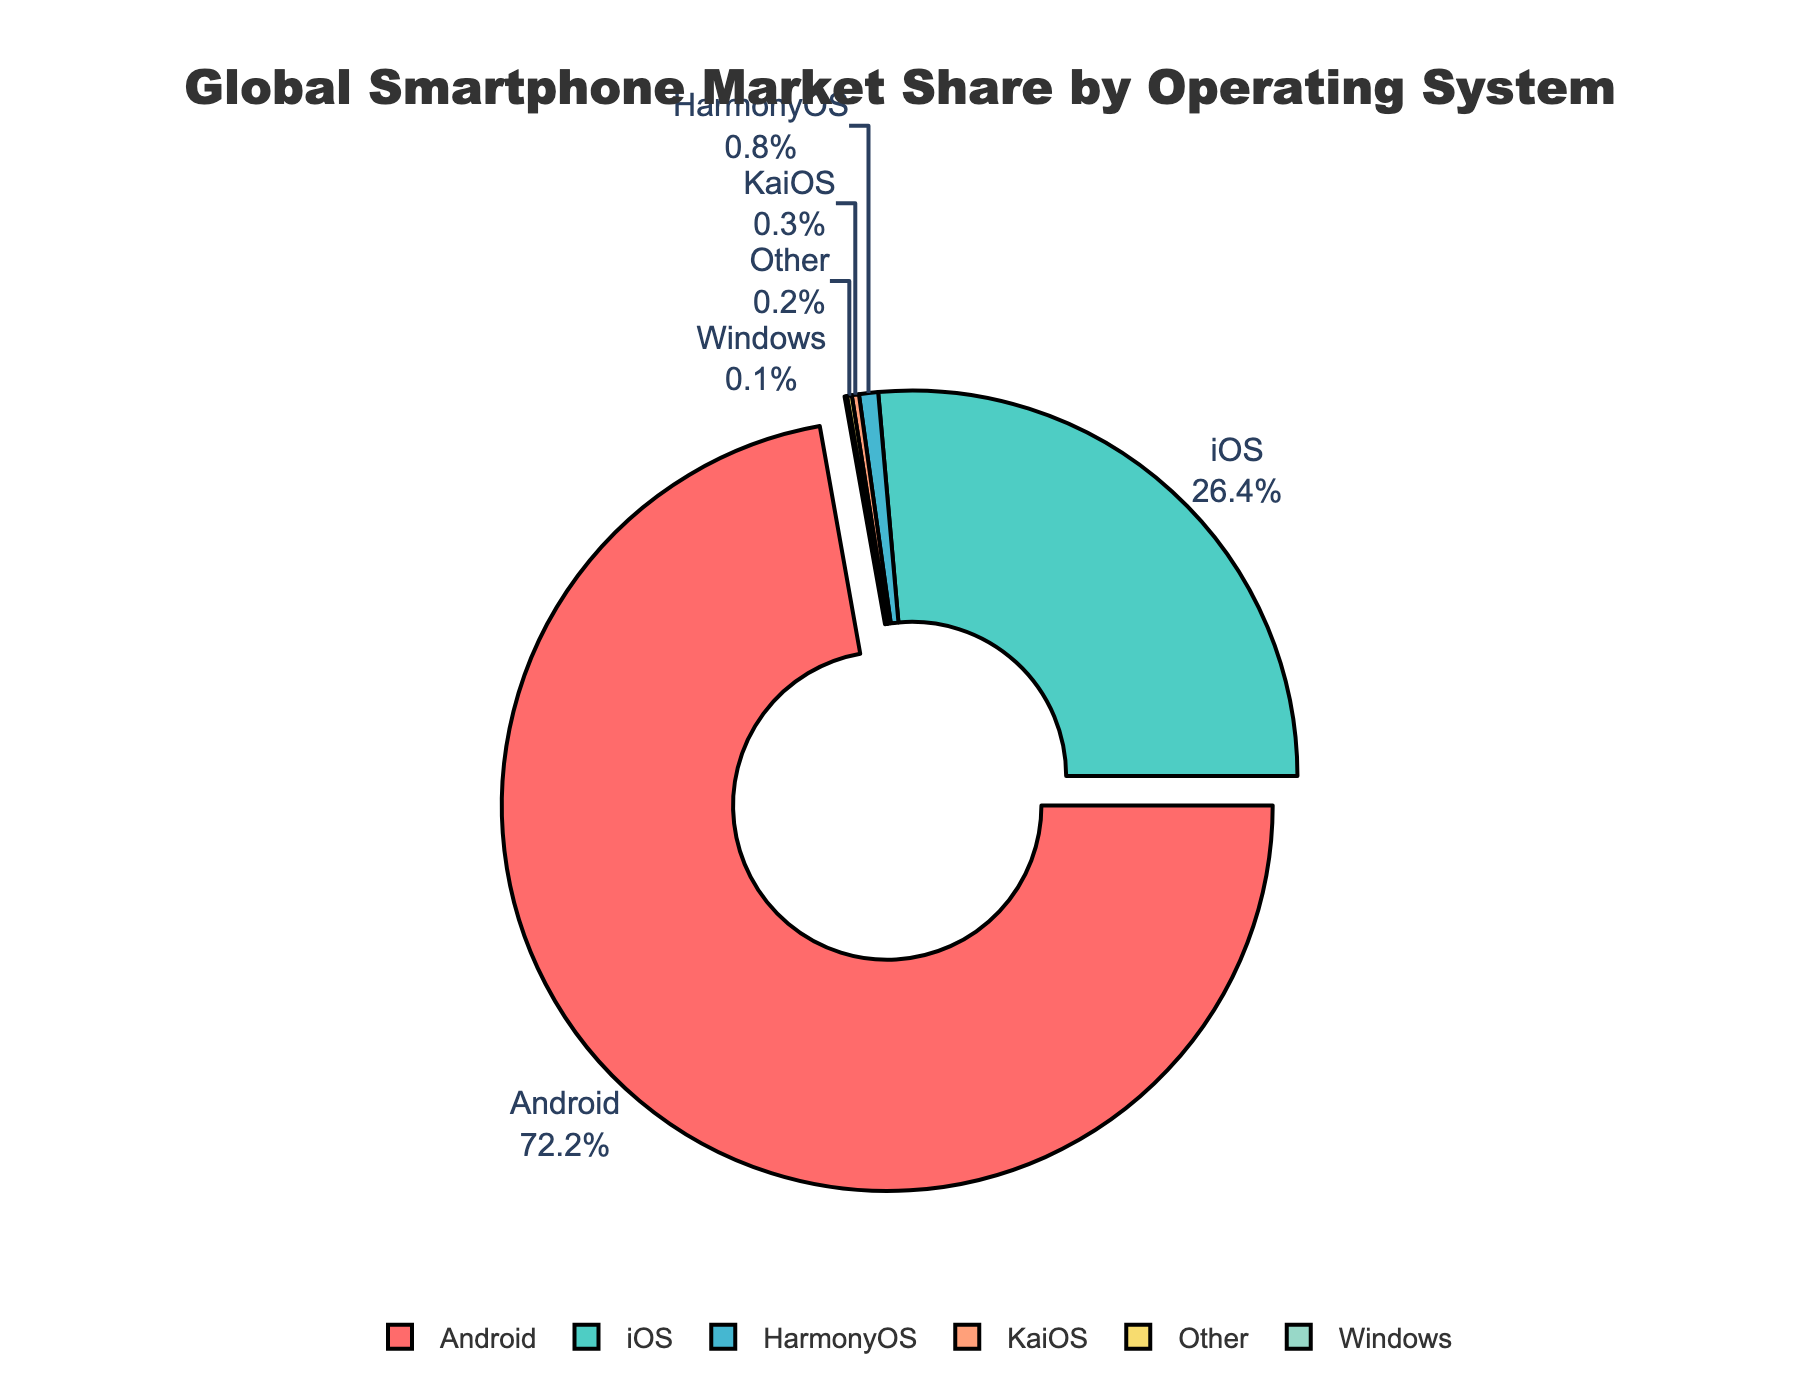What percentage of the market share is held by the top two operating systems combined? Add the market shares of Android (72.2%) and iOS (26.4%) together. Therefore, 72.2 + 26.4 = 98.6%.
Answer: 98.6% Which operating system has the smallest market share, and what is its value? By examining the pie chart, the operating system with the smallest market share is Windows with 0.1%.
Answer: Windows, 0.1% How much larger is Android's market share compared to iOS's market share? Subtract the market share of iOS (26.4%) from Android's market share (72.2%). Therefore, 72.2 - 26.4 = 45.8%.
Answer: 45.8% Ordering from smallest to largest, what are the market shares of the operating systems besides Android and iOS? List the market shares in ascending order: Windows (0.1%), Other (0.2%), KaiOS (0.3%), and HarmonyOS (0.8%).
Answer: Windows: 0.1%, Other: 0.2%, KaiOS: 0.3%, HarmonyOS: 0.8% What color represents the ‘Other’ operating system, and what fraction of the pie chart does it cover? The ‘Other’ operating system is represented by a yellow color and it covers 0.2% of the pie chart. To convert to a fraction, 0.2% out of 100% is 0.2/100 or 1/500.
Answer: Yellow, 1/500 Which operating system is highlighted, and why might this be? Android is highlighted by being pulled out from the rest of the pie chart, likely to emphasize its dominant market share.
Answer: Android Compare the combined market share of HarmonyOS and KaiOS to iOS. Which one is greater and by how much? Combine HarmonyOS (0.8%) and KaiOS (0.3%) for a total of 1.1%; compare this to iOS at 26.4%. iOS is greater by 26.4 - 1.1 = 25.3%.
Answer: iOS, by 25.3% If you were to combine the market shares of all the minor operating systems (HarmonyOS, KaiOS, Windows, and Other), what would be their total market share? Add the market shares of HarmonyOS (0.8%), KaiOS (0.3%), Windows (0.1%), and Other (0.2%) for a total of 1.4%.
Answer: 1.4% What is the visual characteristic used to differentiate Android from the other segments in the pie chart? Android is differentiated by being slightly pulled outwards from the center of the pie chart.
Answer: Pulled outwards If you were to remove the smallest market share segment, what would be the new total percentage represented by the remaining segments? The smallest market share is Windows at 0.1%. Subtract this from 100% to get the new total: 100 - 0.1 = 99.9%.
Answer: 99.9% 